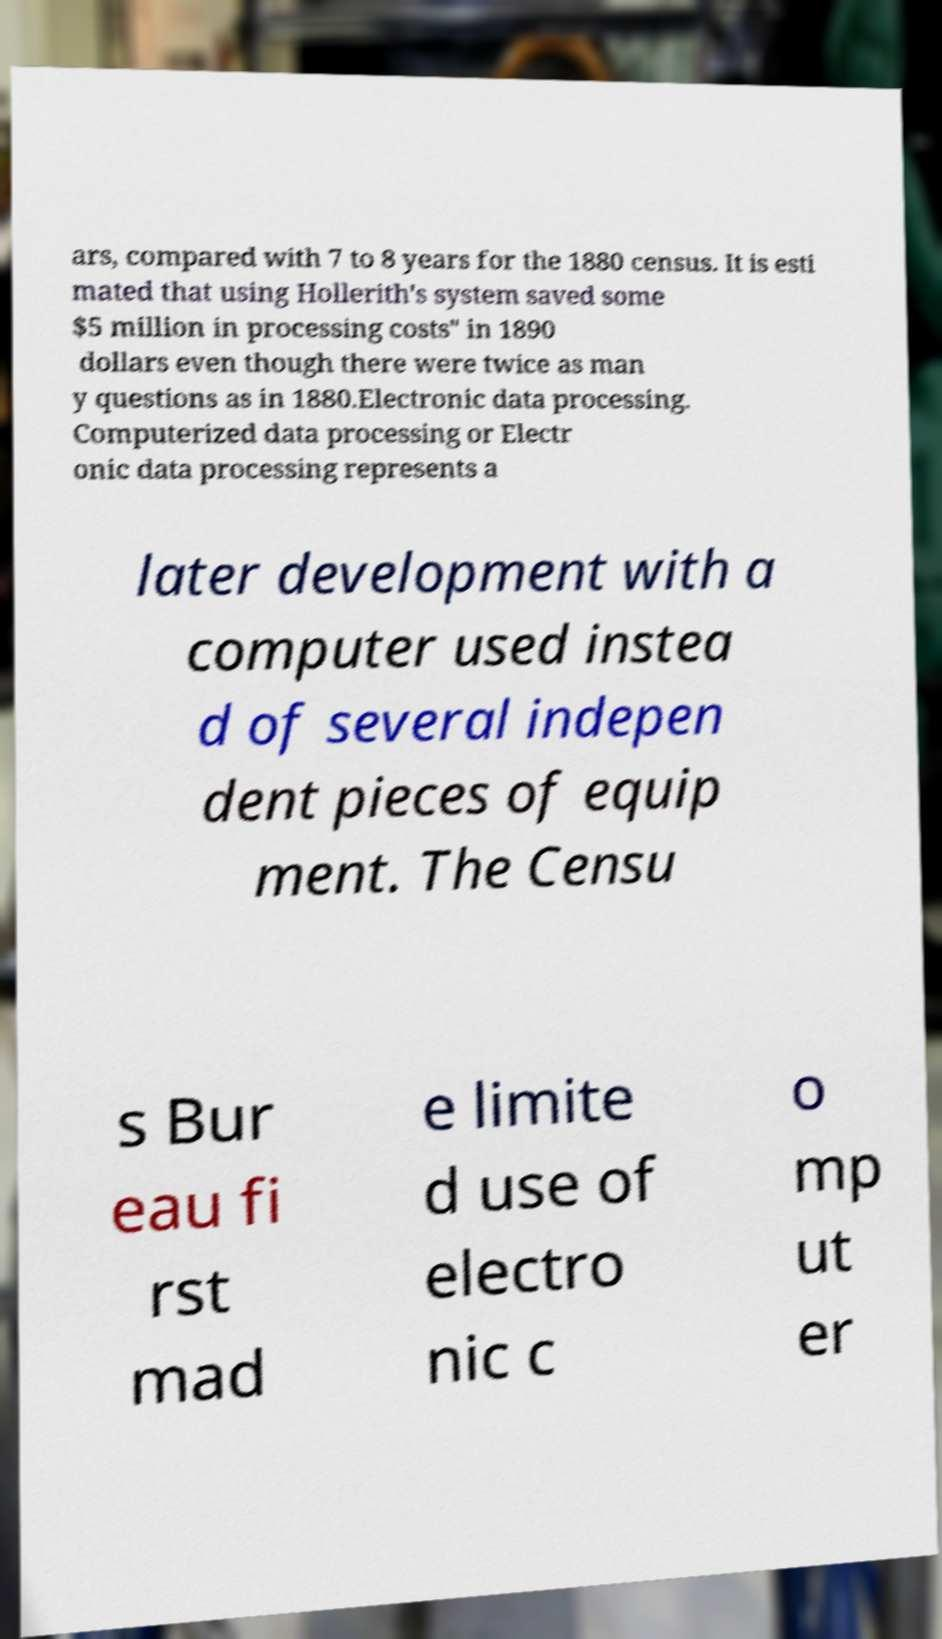For documentation purposes, I need the text within this image transcribed. Could you provide that? ars, compared with 7 to 8 years for the 1880 census. It is esti mated that using Hollerith's system saved some $5 million in processing costs" in 1890 dollars even though there were twice as man y questions as in 1880.Electronic data processing. Computerized data processing or Electr onic data processing represents a later development with a computer used instea d of several indepen dent pieces of equip ment. The Censu s Bur eau fi rst mad e limite d use of electro nic c o mp ut er 